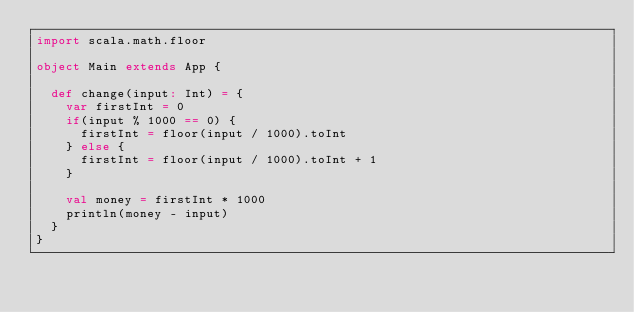Convert code to text. <code><loc_0><loc_0><loc_500><loc_500><_Scala_>import scala.math.floor

object Main extends App {

  def change(input: Int) = {
    var firstInt = 0
    if(input % 1000 == 0) {
      firstInt = floor(input / 1000).toInt
    } else {
      firstInt = floor(input / 1000).toInt + 1
    }
  
    val money = firstInt * 1000
    println(money - input)
  }
}</code> 